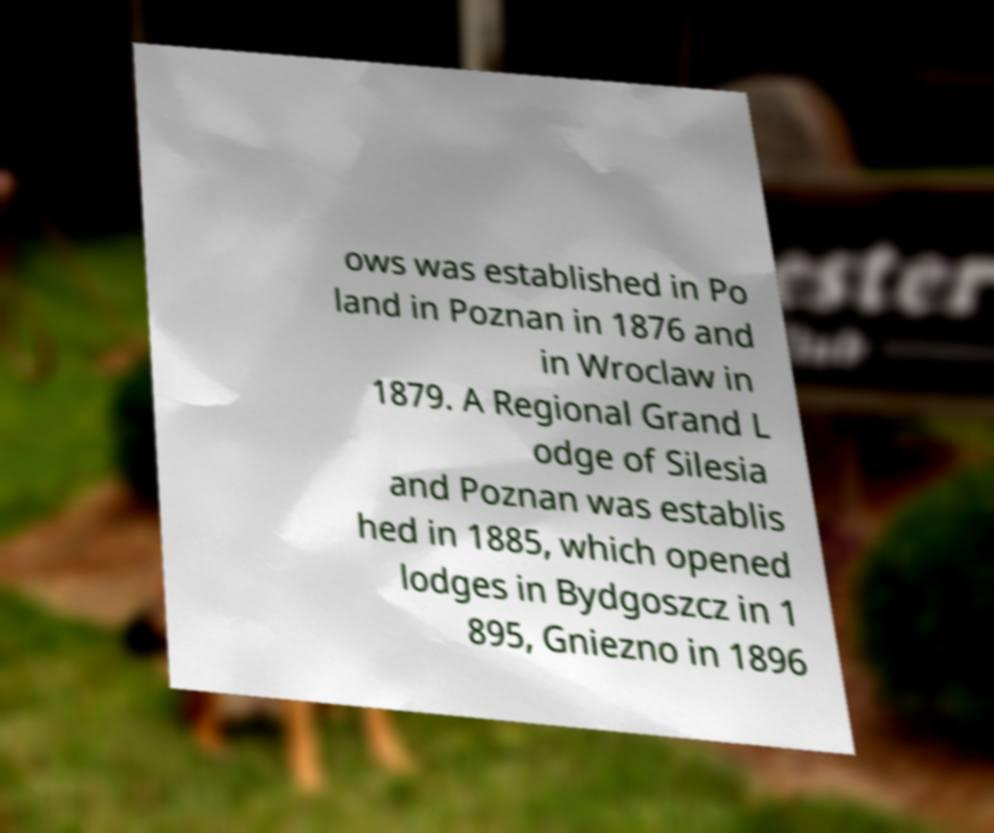Could you extract and type out the text from this image? ows was established in Po land in Poznan in 1876 and in Wroclaw in 1879. A Regional Grand L odge of Silesia and Poznan was establis hed in 1885, which opened lodges in Bydgoszcz in 1 895, Gniezno in 1896 